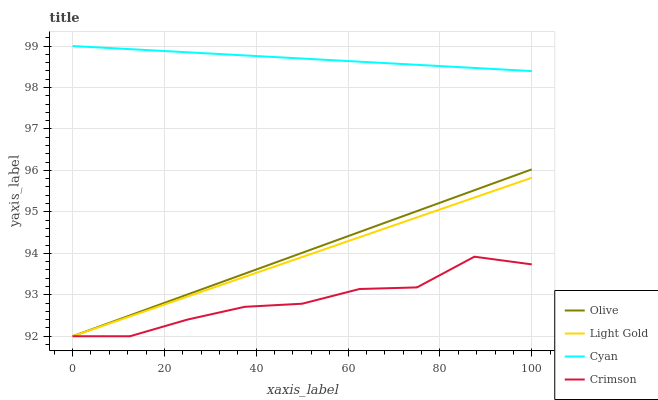Does Light Gold have the minimum area under the curve?
Answer yes or no. No. Does Light Gold have the maximum area under the curve?
Answer yes or no. No. Is Cyan the smoothest?
Answer yes or no. No. Is Cyan the roughest?
Answer yes or no. No. Does Cyan have the lowest value?
Answer yes or no. No. Does Light Gold have the highest value?
Answer yes or no. No. Is Olive less than Cyan?
Answer yes or no. Yes. Is Cyan greater than Crimson?
Answer yes or no. Yes. Does Olive intersect Cyan?
Answer yes or no. No. 